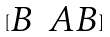Convert formula to latex. <formula><loc_0><loc_0><loc_500><loc_500>[ \begin{matrix} B & A B \end{matrix} ]</formula> 